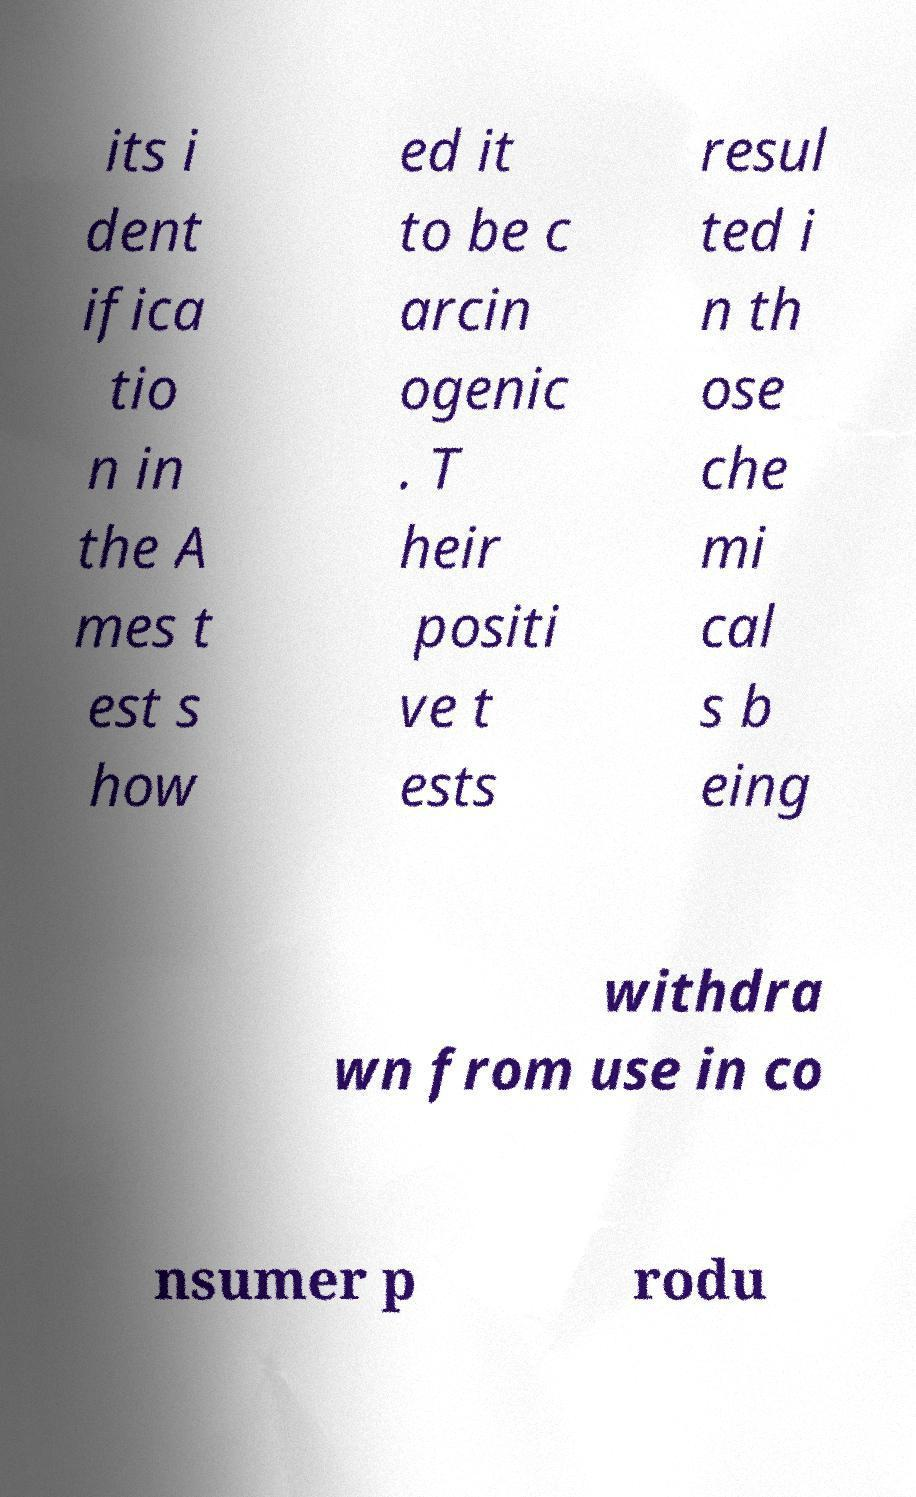Can you read and provide the text displayed in the image?This photo seems to have some interesting text. Can you extract and type it out for me? its i dent ifica tio n in the A mes t est s how ed it to be c arcin ogenic . T heir positi ve t ests resul ted i n th ose che mi cal s b eing withdra wn from use in co nsumer p rodu 